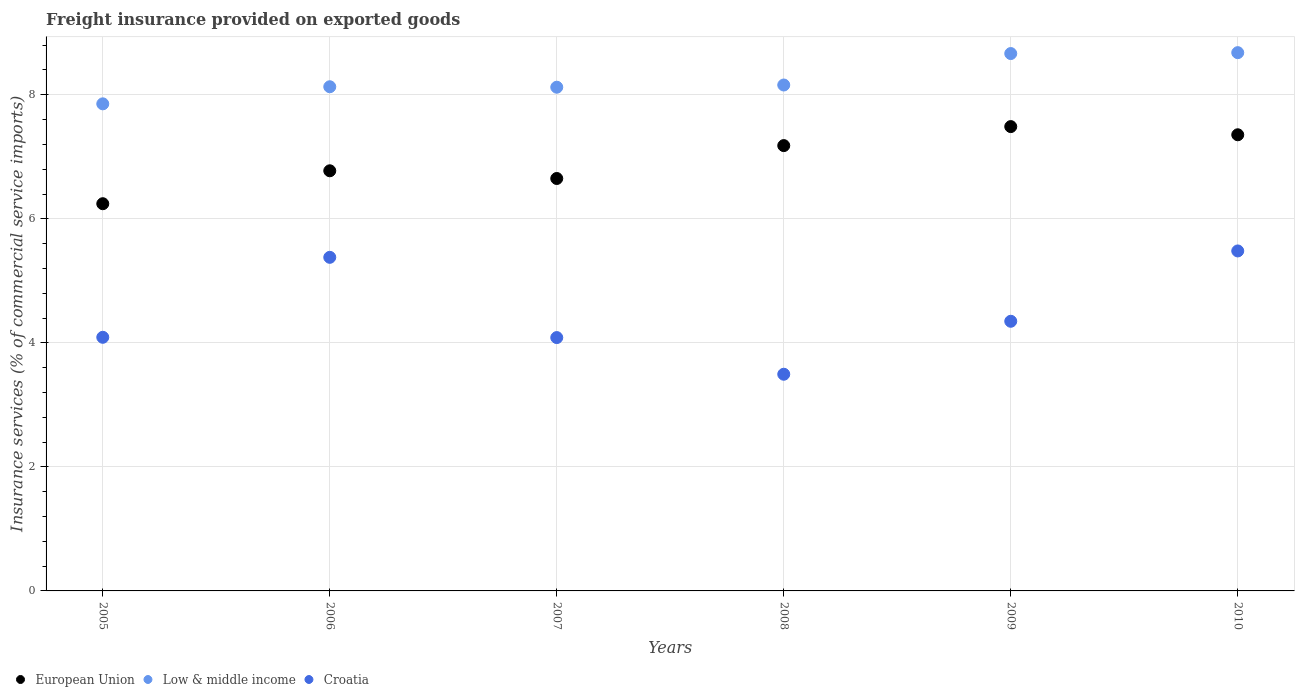Is the number of dotlines equal to the number of legend labels?
Your answer should be compact. Yes. What is the freight insurance provided on exported goods in European Union in 2010?
Your response must be concise. 7.36. Across all years, what is the maximum freight insurance provided on exported goods in Low & middle income?
Your response must be concise. 8.68. Across all years, what is the minimum freight insurance provided on exported goods in Low & middle income?
Your answer should be very brief. 7.85. What is the total freight insurance provided on exported goods in Croatia in the graph?
Your answer should be very brief. 26.88. What is the difference between the freight insurance provided on exported goods in Low & middle income in 2005 and that in 2009?
Offer a terse response. -0.81. What is the difference between the freight insurance provided on exported goods in European Union in 2007 and the freight insurance provided on exported goods in Croatia in 2008?
Provide a short and direct response. 3.16. What is the average freight insurance provided on exported goods in European Union per year?
Make the answer very short. 6.95. In the year 2009, what is the difference between the freight insurance provided on exported goods in Croatia and freight insurance provided on exported goods in European Union?
Keep it short and to the point. -3.14. In how many years, is the freight insurance provided on exported goods in Croatia greater than 5.2 %?
Give a very brief answer. 2. What is the ratio of the freight insurance provided on exported goods in Low & middle income in 2007 to that in 2009?
Offer a very short reply. 0.94. Is the freight insurance provided on exported goods in Croatia in 2006 less than that in 2009?
Offer a very short reply. No. Is the difference between the freight insurance provided on exported goods in Croatia in 2005 and 2010 greater than the difference between the freight insurance provided on exported goods in European Union in 2005 and 2010?
Give a very brief answer. No. What is the difference between the highest and the second highest freight insurance provided on exported goods in European Union?
Ensure brevity in your answer.  0.13. What is the difference between the highest and the lowest freight insurance provided on exported goods in Croatia?
Give a very brief answer. 1.99. Is the sum of the freight insurance provided on exported goods in Croatia in 2008 and 2010 greater than the maximum freight insurance provided on exported goods in European Union across all years?
Offer a terse response. Yes. Is it the case that in every year, the sum of the freight insurance provided on exported goods in European Union and freight insurance provided on exported goods in Low & middle income  is greater than the freight insurance provided on exported goods in Croatia?
Your response must be concise. Yes. How many years are there in the graph?
Provide a succinct answer. 6. What is the difference between two consecutive major ticks on the Y-axis?
Make the answer very short. 2. Where does the legend appear in the graph?
Provide a succinct answer. Bottom left. What is the title of the graph?
Ensure brevity in your answer.  Freight insurance provided on exported goods. Does "Sudan" appear as one of the legend labels in the graph?
Provide a succinct answer. No. What is the label or title of the X-axis?
Your answer should be very brief. Years. What is the label or title of the Y-axis?
Keep it short and to the point. Insurance services (% of commercial service imports). What is the Insurance services (% of commercial service imports) in European Union in 2005?
Ensure brevity in your answer.  6.24. What is the Insurance services (% of commercial service imports) in Low & middle income in 2005?
Offer a terse response. 7.85. What is the Insurance services (% of commercial service imports) of Croatia in 2005?
Your response must be concise. 4.09. What is the Insurance services (% of commercial service imports) of European Union in 2006?
Keep it short and to the point. 6.77. What is the Insurance services (% of commercial service imports) in Low & middle income in 2006?
Offer a terse response. 8.13. What is the Insurance services (% of commercial service imports) of Croatia in 2006?
Offer a very short reply. 5.38. What is the Insurance services (% of commercial service imports) in European Union in 2007?
Keep it short and to the point. 6.65. What is the Insurance services (% of commercial service imports) in Low & middle income in 2007?
Offer a very short reply. 8.12. What is the Insurance services (% of commercial service imports) of Croatia in 2007?
Provide a short and direct response. 4.09. What is the Insurance services (% of commercial service imports) of European Union in 2008?
Give a very brief answer. 7.18. What is the Insurance services (% of commercial service imports) in Low & middle income in 2008?
Ensure brevity in your answer.  8.16. What is the Insurance services (% of commercial service imports) in Croatia in 2008?
Make the answer very short. 3.49. What is the Insurance services (% of commercial service imports) of European Union in 2009?
Provide a short and direct response. 7.49. What is the Insurance services (% of commercial service imports) in Low & middle income in 2009?
Your response must be concise. 8.66. What is the Insurance services (% of commercial service imports) of Croatia in 2009?
Ensure brevity in your answer.  4.35. What is the Insurance services (% of commercial service imports) of European Union in 2010?
Offer a terse response. 7.36. What is the Insurance services (% of commercial service imports) of Low & middle income in 2010?
Make the answer very short. 8.68. What is the Insurance services (% of commercial service imports) in Croatia in 2010?
Keep it short and to the point. 5.48. Across all years, what is the maximum Insurance services (% of commercial service imports) of European Union?
Give a very brief answer. 7.49. Across all years, what is the maximum Insurance services (% of commercial service imports) of Low & middle income?
Provide a succinct answer. 8.68. Across all years, what is the maximum Insurance services (% of commercial service imports) of Croatia?
Make the answer very short. 5.48. Across all years, what is the minimum Insurance services (% of commercial service imports) in European Union?
Provide a succinct answer. 6.24. Across all years, what is the minimum Insurance services (% of commercial service imports) in Low & middle income?
Offer a very short reply. 7.85. Across all years, what is the minimum Insurance services (% of commercial service imports) of Croatia?
Offer a very short reply. 3.49. What is the total Insurance services (% of commercial service imports) in European Union in the graph?
Provide a succinct answer. 41.69. What is the total Insurance services (% of commercial service imports) in Low & middle income in the graph?
Keep it short and to the point. 49.61. What is the total Insurance services (% of commercial service imports) in Croatia in the graph?
Ensure brevity in your answer.  26.88. What is the difference between the Insurance services (% of commercial service imports) in European Union in 2005 and that in 2006?
Keep it short and to the point. -0.53. What is the difference between the Insurance services (% of commercial service imports) of Low & middle income in 2005 and that in 2006?
Give a very brief answer. -0.28. What is the difference between the Insurance services (% of commercial service imports) in Croatia in 2005 and that in 2006?
Offer a terse response. -1.29. What is the difference between the Insurance services (% of commercial service imports) of European Union in 2005 and that in 2007?
Your answer should be very brief. -0.41. What is the difference between the Insurance services (% of commercial service imports) in Low & middle income in 2005 and that in 2007?
Your answer should be very brief. -0.27. What is the difference between the Insurance services (% of commercial service imports) in Croatia in 2005 and that in 2007?
Provide a succinct answer. 0. What is the difference between the Insurance services (% of commercial service imports) of European Union in 2005 and that in 2008?
Give a very brief answer. -0.94. What is the difference between the Insurance services (% of commercial service imports) in Low & middle income in 2005 and that in 2008?
Offer a terse response. -0.3. What is the difference between the Insurance services (% of commercial service imports) in Croatia in 2005 and that in 2008?
Your answer should be very brief. 0.6. What is the difference between the Insurance services (% of commercial service imports) of European Union in 2005 and that in 2009?
Ensure brevity in your answer.  -1.24. What is the difference between the Insurance services (% of commercial service imports) in Low & middle income in 2005 and that in 2009?
Keep it short and to the point. -0.81. What is the difference between the Insurance services (% of commercial service imports) in Croatia in 2005 and that in 2009?
Keep it short and to the point. -0.26. What is the difference between the Insurance services (% of commercial service imports) of European Union in 2005 and that in 2010?
Provide a succinct answer. -1.11. What is the difference between the Insurance services (% of commercial service imports) in Low & middle income in 2005 and that in 2010?
Provide a succinct answer. -0.83. What is the difference between the Insurance services (% of commercial service imports) in Croatia in 2005 and that in 2010?
Make the answer very short. -1.39. What is the difference between the Insurance services (% of commercial service imports) of European Union in 2006 and that in 2007?
Ensure brevity in your answer.  0.12. What is the difference between the Insurance services (% of commercial service imports) of Low & middle income in 2006 and that in 2007?
Provide a succinct answer. 0.01. What is the difference between the Insurance services (% of commercial service imports) of Croatia in 2006 and that in 2007?
Offer a very short reply. 1.29. What is the difference between the Insurance services (% of commercial service imports) in European Union in 2006 and that in 2008?
Your answer should be very brief. -0.41. What is the difference between the Insurance services (% of commercial service imports) of Low & middle income in 2006 and that in 2008?
Offer a terse response. -0.03. What is the difference between the Insurance services (% of commercial service imports) in Croatia in 2006 and that in 2008?
Keep it short and to the point. 1.89. What is the difference between the Insurance services (% of commercial service imports) in European Union in 2006 and that in 2009?
Ensure brevity in your answer.  -0.71. What is the difference between the Insurance services (% of commercial service imports) of Low & middle income in 2006 and that in 2009?
Your response must be concise. -0.54. What is the difference between the Insurance services (% of commercial service imports) in Croatia in 2006 and that in 2009?
Ensure brevity in your answer.  1.03. What is the difference between the Insurance services (% of commercial service imports) of European Union in 2006 and that in 2010?
Your response must be concise. -0.58. What is the difference between the Insurance services (% of commercial service imports) in Low & middle income in 2006 and that in 2010?
Your answer should be compact. -0.55. What is the difference between the Insurance services (% of commercial service imports) of Croatia in 2006 and that in 2010?
Provide a short and direct response. -0.1. What is the difference between the Insurance services (% of commercial service imports) in European Union in 2007 and that in 2008?
Provide a short and direct response. -0.53. What is the difference between the Insurance services (% of commercial service imports) of Low & middle income in 2007 and that in 2008?
Provide a short and direct response. -0.04. What is the difference between the Insurance services (% of commercial service imports) of Croatia in 2007 and that in 2008?
Your answer should be very brief. 0.59. What is the difference between the Insurance services (% of commercial service imports) in European Union in 2007 and that in 2009?
Your answer should be compact. -0.84. What is the difference between the Insurance services (% of commercial service imports) in Low & middle income in 2007 and that in 2009?
Your answer should be compact. -0.54. What is the difference between the Insurance services (% of commercial service imports) in Croatia in 2007 and that in 2009?
Offer a terse response. -0.26. What is the difference between the Insurance services (% of commercial service imports) in European Union in 2007 and that in 2010?
Make the answer very short. -0.7. What is the difference between the Insurance services (% of commercial service imports) in Low & middle income in 2007 and that in 2010?
Your answer should be compact. -0.56. What is the difference between the Insurance services (% of commercial service imports) of Croatia in 2007 and that in 2010?
Offer a terse response. -1.4. What is the difference between the Insurance services (% of commercial service imports) in European Union in 2008 and that in 2009?
Make the answer very short. -0.31. What is the difference between the Insurance services (% of commercial service imports) of Low & middle income in 2008 and that in 2009?
Provide a short and direct response. -0.51. What is the difference between the Insurance services (% of commercial service imports) in Croatia in 2008 and that in 2009?
Offer a very short reply. -0.85. What is the difference between the Insurance services (% of commercial service imports) of European Union in 2008 and that in 2010?
Give a very brief answer. -0.17. What is the difference between the Insurance services (% of commercial service imports) of Low & middle income in 2008 and that in 2010?
Make the answer very short. -0.52. What is the difference between the Insurance services (% of commercial service imports) in Croatia in 2008 and that in 2010?
Your response must be concise. -1.99. What is the difference between the Insurance services (% of commercial service imports) in European Union in 2009 and that in 2010?
Your answer should be compact. 0.13. What is the difference between the Insurance services (% of commercial service imports) of Low & middle income in 2009 and that in 2010?
Offer a very short reply. -0.01. What is the difference between the Insurance services (% of commercial service imports) in Croatia in 2009 and that in 2010?
Keep it short and to the point. -1.13. What is the difference between the Insurance services (% of commercial service imports) of European Union in 2005 and the Insurance services (% of commercial service imports) of Low & middle income in 2006?
Provide a short and direct response. -1.89. What is the difference between the Insurance services (% of commercial service imports) in European Union in 2005 and the Insurance services (% of commercial service imports) in Croatia in 2006?
Provide a short and direct response. 0.86. What is the difference between the Insurance services (% of commercial service imports) of Low & middle income in 2005 and the Insurance services (% of commercial service imports) of Croatia in 2006?
Offer a very short reply. 2.47. What is the difference between the Insurance services (% of commercial service imports) in European Union in 2005 and the Insurance services (% of commercial service imports) in Low & middle income in 2007?
Keep it short and to the point. -1.88. What is the difference between the Insurance services (% of commercial service imports) of European Union in 2005 and the Insurance services (% of commercial service imports) of Croatia in 2007?
Offer a terse response. 2.16. What is the difference between the Insurance services (% of commercial service imports) of Low & middle income in 2005 and the Insurance services (% of commercial service imports) of Croatia in 2007?
Provide a succinct answer. 3.77. What is the difference between the Insurance services (% of commercial service imports) in European Union in 2005 and the Insurance services (% of commercial service imports) in Low & middle income in 2008?
Give a very brief answer. -1.91. What is the difference between the Insurance services (% of commercial service imports) of European Union in 2005 and the Insurance services (% of commercial service imports) of Croatia in 2008?
Ensure brevity in your answer.  2.75. What is the difference between the Insurance services (% of commercial service imports) of Low & middle income in 2005 and the Insurance services (% of commercial service imports) of Croatia in 2008?
Offer a terse response. 4.36. What is the difference between the Insurance services (% of commercial service imports) of European Union in 2005 and the Insurance services (% of commercial service imports) of Low & middle income in 2009?
Your response must be concise. -2.42. What is the difference between the Insurance services (% of commercial service imports) in European Union in 2005 and the Insurance services (% of commercial service imports) in Croatia in 2009?
Make the answer very short. 1.9. What is the difference between the Insurance services (% of commercial service imports) in Low & middle income in 2005 and the Insurance services (% of commercial service imports) in Croatia in 2009?
Provide a short and direct response. 3.51. What is the difference between the Insurance services (% of commercial service imports) of European Union in 2005 and the Insurance services (% of commercial service imports) of Low & middle income in 2010?
Your answer should be very brief. -2.44. What is the difference between the Insurance services (% of commercial service imports) in European Union in 2005 and the Insurance services (% of commercial service imports) in Croatia in 2010?
Your answer should be compact. 0.76. What is the difference between the Insurance services (% of commercial service imports) in Low & middle income in 2005 and the Insurance services (% of commercial service imports) in Croatia in 2010?
Ensure brevity in your answer.  2.37. What is the difference between the Insurance services (% of commercial service imports) of European Union in 2006 and the Insurance services (% of commercial service imports) of Low & middle income in 2007?
Ensure brevity in your answer.  -1.35. What is the difference between the Insurance services (% of commercial service imports) in European Union in 2006 and the Insurance services (% of commercial service imports) in Croatia in 2007?
Offer a terse response. 2.69. What is the difference between the Insurance services (% of commercial service imports) of Low & middle income in 2006 and the Insurance services (% of commercial service imports) of Croatia in 2007?
Offer a terse response. 4.04. What is the difference between the Insurance services (% of commercial service imports) of European Union in 2006 and the Insurance services (% of commercial service imports) of Low & middle income in 2008?
Offer a terse response. -1.38. What is the difference between the Insurance services (% of commercial service imports) of European Union in 2006 and the Insurance services (% of commercial service imports) of Croatia in 2008?
Provide a short and direct response. 3.28. What is the difference between the Insurance services (% of commercial service imports) in Low & middle income in 2006 and the Insurance services (% of commercial service imports) in Croatia in 2008?
Make the answer very short. 4.64. What is the difference between the Insurance services (% of commercial service imports) in European Union in 2006 and the Insurance services (% of commercial service imports) in Low & middle income in 2009?
Your answer should be compact. -1.89. What is the difference between the Insurance services (% of commercial service imports) of European Union in 2006 and the Insurance services (% of commercial service imports) of Croatia in 2009?
Ensure brevity in your answer.  2.43. What is the difference between the Insurance services (% of commercial service imports) of Low & middle income in 2006 and the Insurance services (% of commercial service imports) of Croatia in 2009?
Make the answer very short. 3.78. What is the difference between the Insurance services (% of commercial service imports) in European Union in 2006 and the Insurance services (% of commercial service imports) in Low & middle income in 2010?
Your answer should be very brief. -1.9. What is the difference between the Insurance services (% of commercial service imports) of European Union in 2006 and the Insurance services (% of commercial service imports) of Croatia in 2010?
Provide a succinct answer. 1.29. What is the difference between the Insurance services (% of commercial service imports) in Low & middle income in 2006 and the Insurance services (% of commercial service imports) in Croatia in 2010?
Provide a short and direct response. 2.65. What is the difference between the Insurance services (% of commercial service imports) of European Union in 2007 and the Insurance services (% of commercial service imports) of Low & middle income in 2008?
Your response must be concise. -1.51. What is the difference between the Insurance services (% of commercial service imports) of European Union in 2007 and the Insurance services (% of commercial service imports) of Croatia in 2008?
Provide a succinct answer. 3.16. What is the difference between the Insurance services (% of commercial service imports) of Low & middle income in 2007 and the Insurance services (% of commercial service imports) of Croatia in 2008?
Give a very brief answer. 4.63. What is the difference between the Insurance services (% of commercial service imports) in European Union in 2007 and the Insurance services (% of commercial service imports) in Low & middle income in 2009?
Give a very brief answer. -2.01. What is the difference between the Insurance services (% of commercial service imports) in European Union in 2007 and the Insurance services (% of commercial service imports) in Croatia in 2009?
Keep it short and to the point. 2.3. What is the difference between the Insurance services (% of commercial service imports) in Low & middle income in 2007 and the Insurance services (% of commercial service imports) in Croatia in 2009?
Give a very brief answer. 3.77. What is the difference between the Insurance services (% of commercial service imports) in European Union in 2007 and the Insurance services (% of commercial service imports) in Low & middle income in 2010?
Give a very brief answer. -2.03. What is the difference between the Insurance services (% of commercial service imports) in European Union in 2007 and the Insurance services (% of commercial service imports) in Croatia in 2010?
Your answer should be compact. 1.17. What is the difference between the Insurance services (% of commercial service imports) of Low & middle income in 2007 and the Insurance services (% of commercial service imports) of Croatia in 2010?
Offer a very short reply. 2.64. What is the difference between the Insurance services (% of commercial service imports) in European Union in 2008 and the Insurance services (% of commercial service imports) in Low & middle income in 2009?
Your response must be concise. -1.48. What is the difference between the Insurance services (% of commercial service imports) of European Union in 2008 and the Insurance services (% of commercial service imports) of Croatia in 2009?
Offer a terse response. 2.83. What is the difference between the Insurance services (% of commercial service imports) in Low & middle income in 2008 and the Insurance services (% of commercial service imports) in Croatia in 2009?
Your answer should be very brief. 3.81. What is the difference between the Insurance services (% of commercial service imports) in European Union in 2008 and the Insurance services (% of commercial service imports) in Low & middle income in 2010?
Ensure brevity in your answer.  -1.5. What is the difference between the Insurance services (% of commercial service imports) in European Union in 2008 and the Insurance services (% of commercial service imports) in Croatia in 2010?
Provide a short and direct response. 1.7. What is the difference between the Insurance services (% of commercial service imports) in Low & middle income in 2008 and the Insurance services (% of commercial service imports) in Croatia in 2010?
Keep it short and to the point. 2.68. What is the difference between the Insurance services (% of commercial service imports) of European Union in 2009 and the Insurance services (% of commercial service imports) of Low & middle income in 2010?
Your answer should be compact. -1.19. What is the difference between the Insurance services (% of commercial service imports) of European Union in 2009 and the Insurance services (% of commercial service imports) of Croatia in 2010?
Ensure brevity in your answer.  2. What is the difference between the Insurance services (% of commercial service imports) of Low & middle income in 2009 and the Insurance services (% of commercial service imports) of Croatia in 2010?
Provide a short and direct response. 3.18. What is the average Insurance services (% of commercial service imports) of European Union per year?
Your answer should be very brief. 6.95. What is the average Insurance services (% of commercial service imports) in Low & middle income per year?
Your response must be concise. 8.27. What is the average Insurance services (% of commercial service imports) in Croatia per year?
Your answer should be compact. 4.48. In the year 2005, what is the difference between the Insurance services (% of commercial service imports) of European Union and Insurance services (% of commercial service imports) of Low & middle income?
Offer a very short reply. -1.61. In the year 2005, what is the difference between the Insurance services (% of commercial service imports) in European Union and Insurance services (% of commercial service imports) in Croatia?
Provide a short and direct response. 2.15. In the year 2005, what is the difference between the Insurance services (% of commercial service imports) of Low & middle income and Insurance services (% of commercial service imports) of Croatia?
Offer a very short reply. 3.76. In the year 2006, what is the difference between the Insurance services (% of commercial service imports) of European Union and Insurance services (% of commercial service imports) of Low & middle income?
Give a very brief answer. -1.35. In the year 2006, what is the difference between the Insurance services (% of commercial service imports) in European Union and Insurance services (% of commercial service imports) in Croatia?
Make the answer very short. 1.4. In the year 2006, what is the difference between the Insurance services (% of commercial service imports) of Low & middle income and Insurance services (% of commercial service imports) of Croatia?
Provide a succinct answer. 2.75. In the year 2007, what is the difference between the Insurance services (% of commercial service imports) of European Union and Insurance services (% of commercial service imports) of Low & middle income?
Keep it short and to the point. -1.47. In the year 2007, what is the difference between the Insurance services (% of commercial service imports) of European Union and Insurance services (% of commercial service imports) of Croatia?
Provide a succinct answer. 2.57. In the year 2007, what is the difference between the Insurance services (% of commercial service imports) in Low & middle income and Insurance services (% of commercial service imports) in Croatia?
Offer a terse response. 4.04. In the year 2008, what is the difference between the Insurance services (% of commercial service imports) of European Union and Insurance services (% of commercial service imports) of Low & middle income?
Ensure brevity in your answer.  -0.98. In the year 2008, what is the difference between the Insurance services (% of commercial service imports) in European Union and Insurance services (% of commercial service imports) in Croatia?
Ensure brevity in your answer.  3.69. In the year 2008, what is the difference between the Insurance services (% of commercial service imports) of Low & middle income and Insurance services (% of commercial service imports) of Croatia?
Give a very brief answer. 4.66. In the year 2009, what is the difference between the Insurance services (% of commercial service imports) of European Union and Insurance services (% of commercial service imports) of Low & middle income?
Provide a short and direct response. -1.18. In the year 2009, what is the difference between the Insurance services (% of commercial service imports) of European Union and Insurance services (% of commercial service imports) of Croatia?
Keep it short and to the point. 3.14. In the year 2009, what is the difference between the Insurance services (% of commercial service imports) in Low & middle income and Insurance services (% of commercial service imports) in Croatia?
Offer a very short reply. 4.32. In the year 2010, what is the difference between the Insurance services (% of commercial service imports) of European Union and Insurance services (% of commercial service imports) of Low & middle income?
Make the answer very short. -1.32. In the year 2010, what is the difference between the Insurance services (% of commercial service imports) in European Union and Insurance services (% of commercial service imports) in Croatia?
Provide a succinct answer. 1.87. In the year 2010, what is the difference between the Insurance services (% of commercial service imports) of Low & middle income and Insurance services (% of commercial service imports) of Croatia?
Offer a terse response. 3.2. What is the ratio of the Insurance services (% of commercial service imports) of European Union in 2005 to that in 2006?
Keep it short and to the point. 0.92. What is the ratio of the Insurance services (% of commercial service imports) in Low & middle income in 2005 to that in 2006?
Offer a very short reply. 0.97. What is the ratio of the Insurance services (% of commercial service imports) in Croatia in 2005 to that in 2006?
Offer a terse response. 0.76. What is the ratio of the Insurance services (% of commercial service imports) in European Union in 2005 to that in 2007?
Your answer should be compact. 0.94. What is the ratio of the Insurance services (% of commercial service imports) of Croatia in 2005 to that in 2007?
Provide a succinct answer. 1. What is the ratio of the Insurance services (% of commercial service imports) of European Union in 2005 to that in 2008?
Keep it short and to the point. 0.87. What is the ratio of the Insurance services (% of commercial service imports) in Low & middle income in 2005 to that in 2008?
Your response must be concise. 0.96. What is the ratio of the Insurance services (% of commercial service imports) in Croatia in 2005 to that in 2008?
Provide a short and direct response. 1.17. What is the ratio of the Insurance services (% of commercial service imports) of European Union in 2005 to that in 2009?
Give a very brief answer. 0.83. What is the ratio of the Insurance services (% of commercial service imports) of Low & middle income in 2005 to that in 2009?
Offer a very short reply. 0.91. What is the ratio of the Insurance services (% of commercial service imports) in Croatia in 2005 to that in 2009?
Provide a succinct answer. 0.94. What is the ratio of the Insurance services (% of commercial service imports) in European Union in 2005 to that in 2010?
Offer a very short reply. 0.85. What is the ratio of the Insurance services (% of commercial service imports) in Low & middle income in 2005 to that in 2010?
Your response must be concise. 0.9. What is the ratio of the Insurance services (% of commercial service imports) in Croatia in 2005 to that in 2010?
Offer a terse response. 0.75. What is the ratio of the Insurance services (% of commercial service imports) in European Union in 2006 to that in 2007?
Offer a very short reply. 1.02. What is the ratio of the Insurance services (% of commercial service imports) of Croatia in 2006 to that in 2007?
Your response must be concise. 1.32. What is the ratio of the Insurance services (% of commercial service imports) in European Union in 2006 to that in 2008?
Provide a short and direct response. 0.94. What is the ratio of the Insurance services (% of commercial service imports) in Low & middle income in 2006 to that in 2008?
Make the answer very short. 1. What is the ratio of the Insurance services (% of commercial service imports) of Croatia in 2006 to that in 2008?
Offer a terse response. 1.54. What is the ratio of the Insurance services (% of commercial service imports) of European Union in 2006 to that in 2009?
Your answer should be compact. 0.9. What is the ratio of the Insurance services (% of commercial service imports) of Low & middle income in 2006 to that in 2009?
Make the answer very short. 0.94. What is the ratio of the Insurance services (% of commercial service imports) in Croatia in 2006 to that in 2009?
Offer a terse response. 1.24. What is the ratio of the Insurance services (% of commercial service imports) in European Union in 2006 to that in 2010?
Make the answer very short. 0.92. What is the ratio of the Insurance services (% of commercial service imports) of Low & middle income in 2006 to that in 2010?
Ensure brevity in your answer.  0.94. What is the ratio of the Insurance services (% of commercial service imports) in Croatia in 2006 to that in 2010?
Your answer should be very brief. 0.98. What is the ratio of the Insurance services (% of commercial service imports) in European Union in 2007 to that in 2008?
Ensure brevity in your answer.  0.93. What is the ratio of the Insurance services (% of commercial service imports) in Croatia in 2007 to that in 2008?
Offer a very short reply. 1.17. What is the ratio of the Insurance services (% of commercial service imports) of European Union in 2007 to that in 2009?
Your response must be concise. 0.89. What is the ratio of the Insurance services (% of commercial service imports) in Low & middle income in 2007 to that in 2009?
Your answer should be very brief. 0.94. What is the ratio of the Insurance services (% of commercial service imports) in Croatia in 2007 to that in 2009?
Provide a succinct answer. 0.94. What is the ratio of the Insurance services (% of commercial service imports) of European Union in 2007 to that in 2010?
Make the answer very short. 0.9. What is the ratio of the Insurance services (% of commercial service imports) of Low & middle income in 2007 to that in 2010?
Your answer should be very brief. 0.94. What is the ratio of the Insurance services (% of commercial service imports) of Croatia in 2007 to that in 2010?
Offer a very short reply. 0.75. What is the ratio of the Insurance services (% of commercial service imports) of European Union in 2008 to that in 2009?
Provide a short and direct response. 0.96. What is the ratio of the Insurance services (% of commercial service imports) in Low & middle income in 2008 to that in 2009?
Make the answer very short. 0.94. What is the ratio of the Insurance services (% of commercial service imports) in Croatia in 2008 to that in 2009?
Keep it short and to the point. 0.8. What is the ratio of the Insurance services (% of commercial service imports) of European Union in 2008 to that in 2010?
Offer a terse response. 0.98. What is the ratio of the Insurance services (% of commercial service imports) in Low & middle income in 2008 to that in 2010?
Your response must be concise. 0.94. What is the ratio of the Insurance services (% of commercial service imports) of Croatia in 2008 to that in 2010?
Make the answer very short. 0.64. What is the ratio of the Insurance services (% of commercial service imports) in European Union in 2009 to that in 2010?
Your answer should be very brief. 1.02. What is the ratio of the Insurance services (% of commercial service imports) of Croatia in 2009 to that in 2010?
Ensure brevity in your answer.  0.79. What is the difference between the highest and the second highest Insurance services (% of commercial service imports) in European Union?
Provide a succinct answer. 0.13. What is the difference between the highest and the second highest Insurance services (% of commercial service imports) of Low & middle income?
Keep it short and to the point. 0.01. What is the difference between the highest and the second highest Insurance services (% of commercial service imports) of Croatia?
Offer a terse response. 0.1. What is the difference between the highest and the lowest Insurance services (% of commercial service imports) of European Union?
Provide a short and direct response. 1.24. What is the difference between the highest and the lowest Insurance services (% of commercial service imports) of Low & middle income?
Your response must be concise. 0.83. What is the difference between the highest and the lowest Insurance services (% of commercial service imports) of Croatia?
Your answer should be very brief. 1.99. 